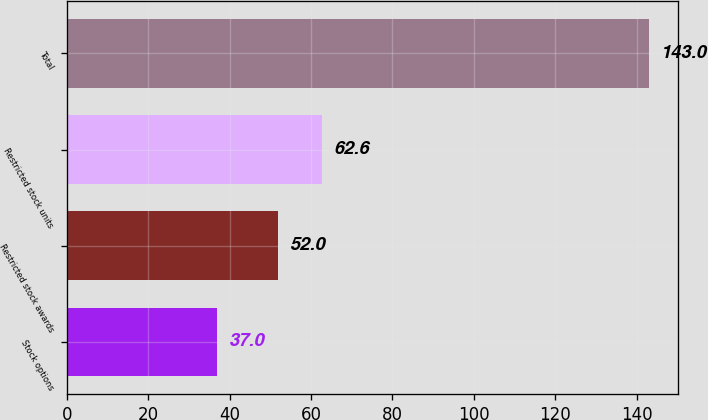Convert chart. <chart><loc_0><loc_0><loc_500><loc_500><bar_chart><fcel>Stock options<fcel>Restricted stock awards<fcel>Restricted stock units<fcel>Total<nl><fcel>37<fcel>52<fcel>62.6<fcel>143<nl></chart> 